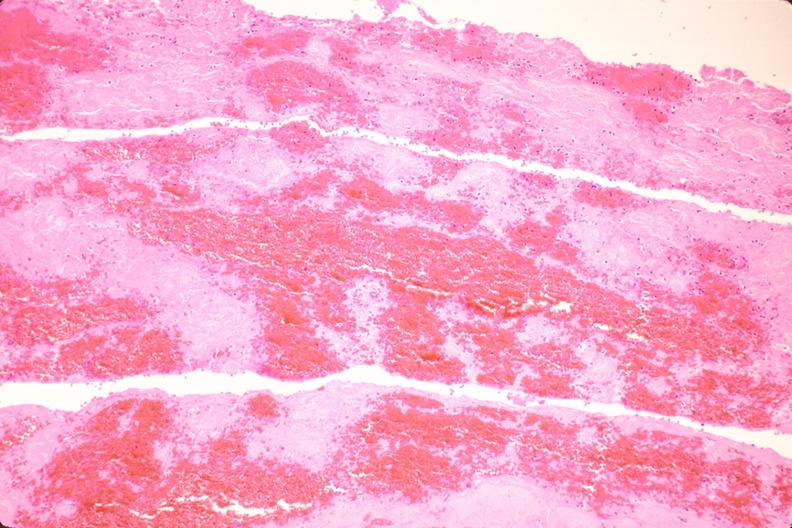what is present?
Answer the question using a single word or phrase. Vasculature 